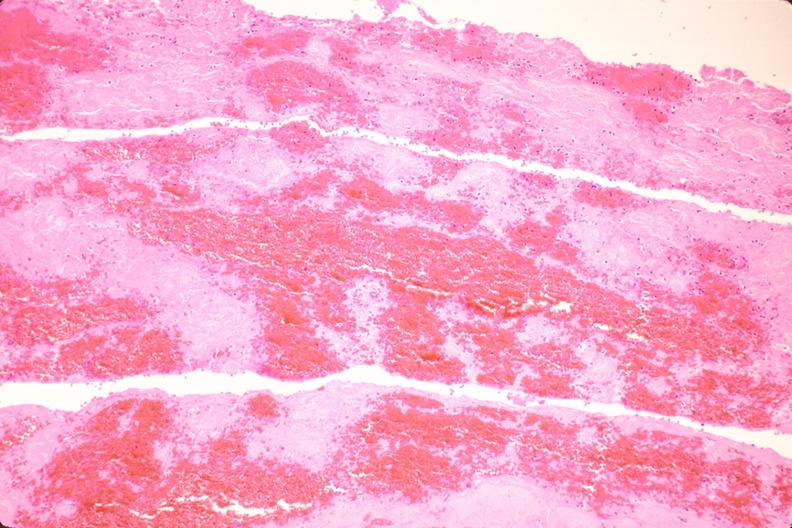what is present?
Answer the question using a single word or phrase. Vasculature 